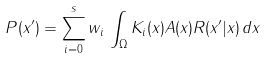<formula> <loc_0><loc_0><loc_500><loc_500>P ( x ^ { \prime } ) = \sum _ { i = 0 } ^ { s } w _ { i } \, \int _ { \Omega } K _ { i } ( x ) A ( x ) R ( x ^ { \prime } | x ) \, d x</formula> 